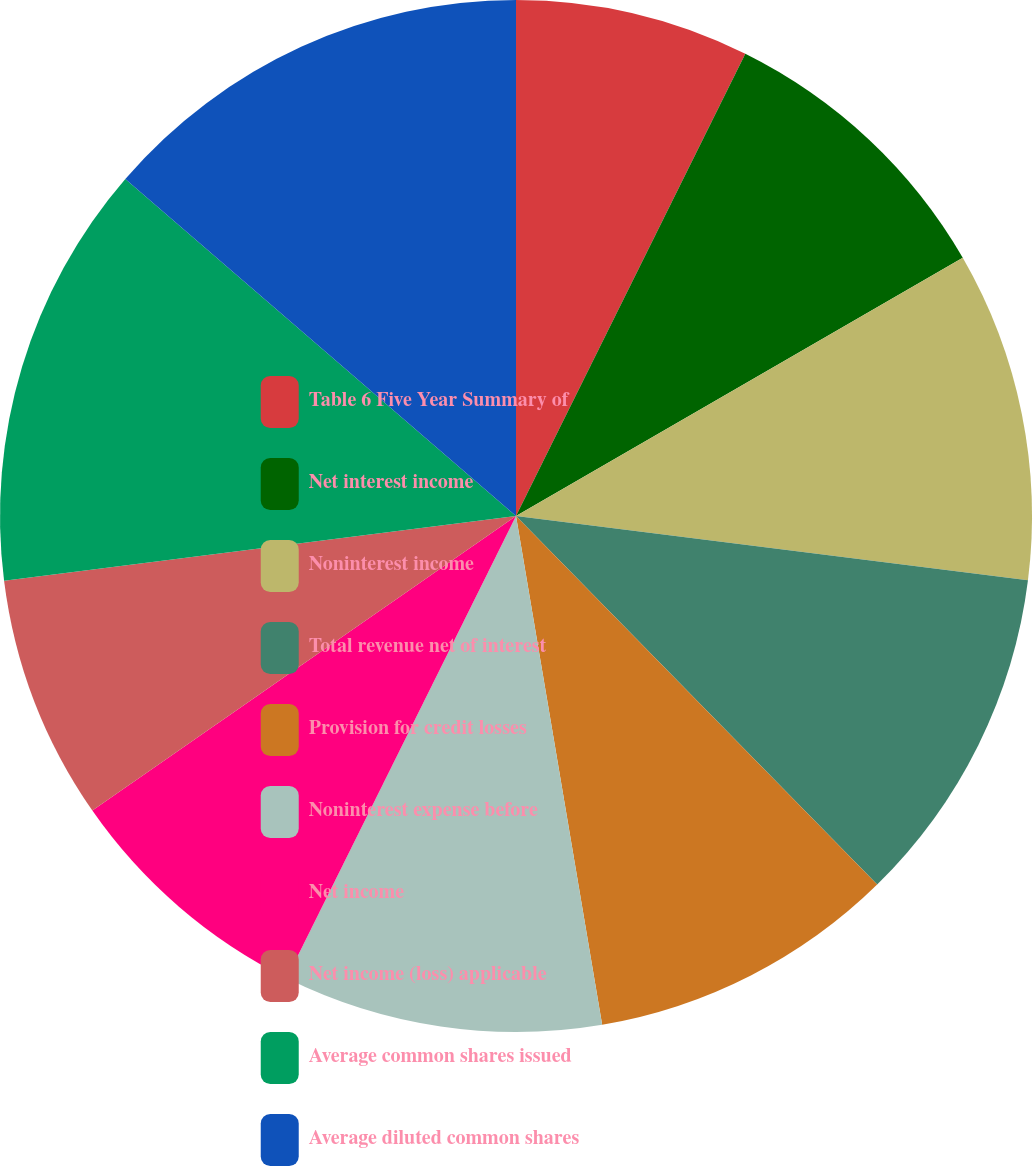<chart> <loc_0><loc_0><loc_500><loc_500><pie_chart><fcel>Table 6 Five Year Summary of<fcel>Net interest income<fcel>Noninterest income<fcel>Total revenue net of interest<fcel>Provision for credit losses<fcel>Noninterest expense before<fcel>Net income<fcel>Net income (loss) applicable<fcel>Average common shares issued<fcel>Average diluted common shares<nl><fcel>7.33%<fcel>9.33%<fcel>10.33%<fcel>10.67%<fcel>9.67%<fcel>10.0%<fcel>8.0%<fcel>7.67%<fcel>13.33%<fcel>13.67%<nl></chart> 